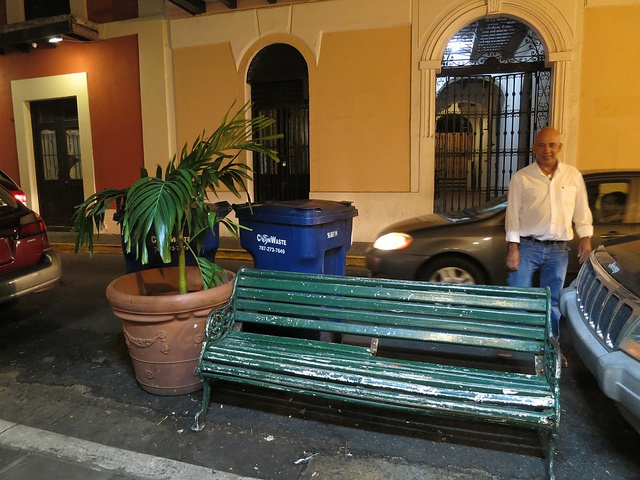Describe the objects in this image and their specific colors. I can see bench in black and teal tones, potted plant in black, olive, maroon, and gray tones, car in black, maroon, and olive tones, car in black, gray, navy, and maroon tones, and people in black and tan tones in this image. 